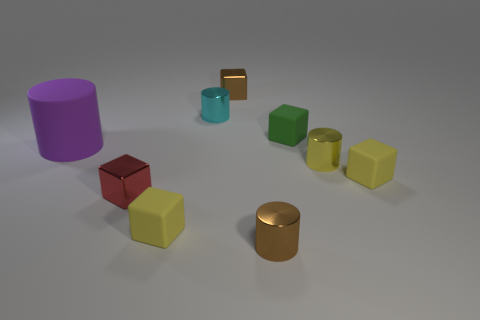Subtract 1 cylinders. How many cylinders are left? 3 Subtract all gray cubes. Subtract all cyan spheres. How many cubes are left? 5 Add 1 big cylinders. How many objects exist? 10 Subtract all cylinders. How many objects are left? 5 Add 8 tiny brown cylinders. How many tiny brown cylinders are left? 9 Add 8 large green metal objects. How many large green metal objects exist? 8 Subtract 0 gray cylinders. How many objects are left? 9 Subtract all green rubber cylinders. Subtract all tiny brown metallic cubes. How many objects are left? 8 